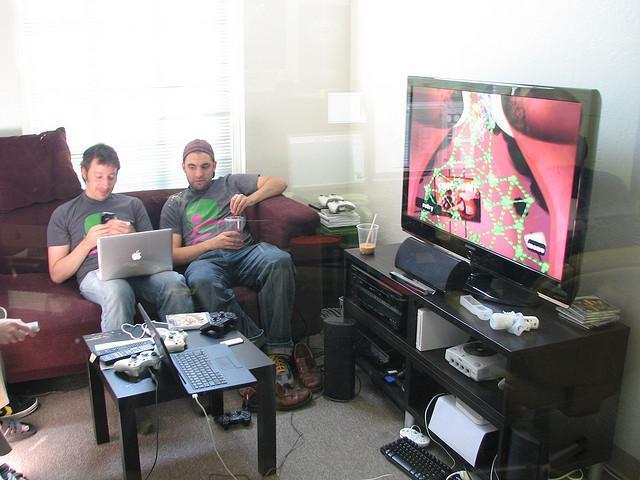How many people are wearing jeans?
Give a very brief answer. 2. How many people can you see?
Give a very brief answer. 2. How many couches can be seen?
Give a very brief answer. 3. How many laptops are in the photo?
Give a very brief answer. 2. How many people are wearing a tie in the picture?
Give a very brief answer. 0. 